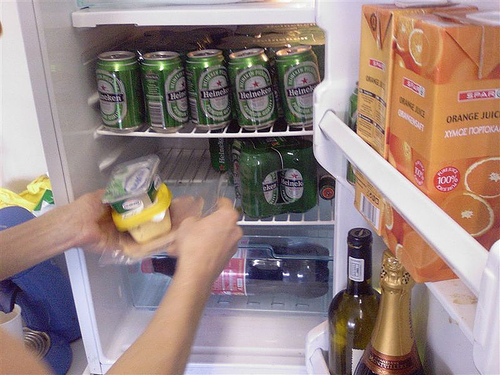Read and extract the text from this image. Heineken Heineken Heineken Heineken Heineken SPAR JUIC ORANGE Heineken Heineken Heineken Heineken Heineken 